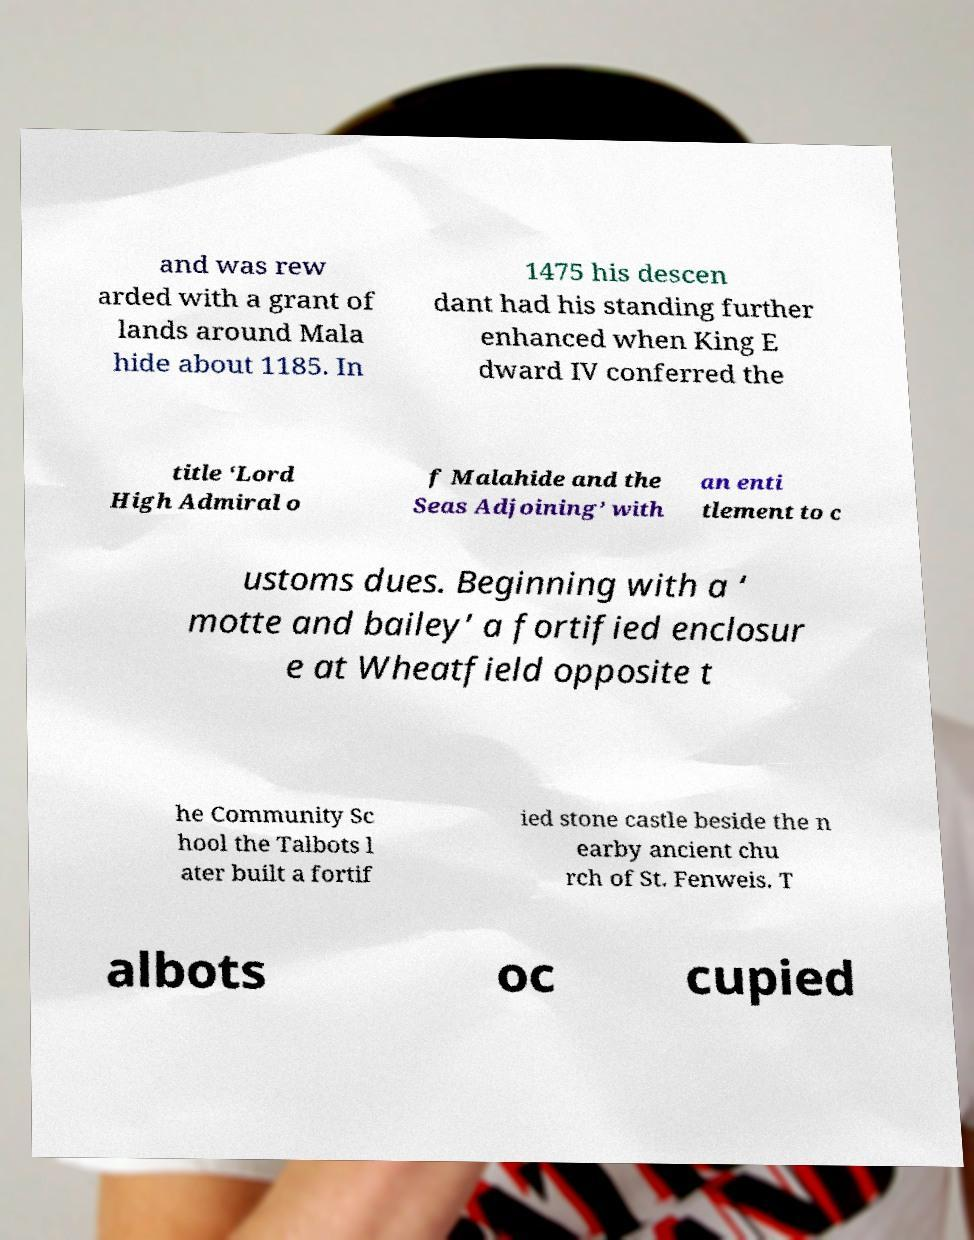For documentation purposes, I need the text within this image transcribed. Could you provide that? and was rew arded with a grant of lands around Mala hide about 1185. In 1475 his descen dant had his standing further enhanced when King E dward IV conferred the title ‘Lord High Admiral o f Malahide and the Seas Adjoining’ with an enti tlement to c ustoms dues. Beginning with a ‘ motte and bailey’ a fortified enclosur e at Wheatfield opposite t he Community Sc hool the Talbots l ater built a fortif ied stone castle beside the n earby ancient chu rch of St. Fenweis. T albots oc cupied 